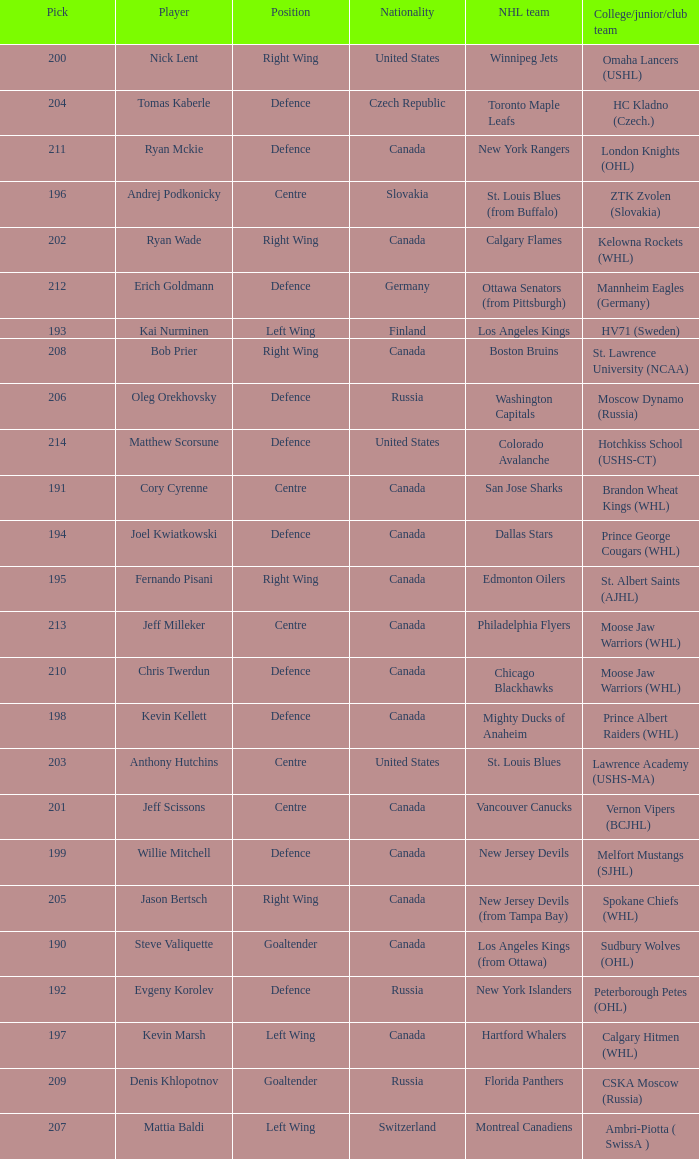Name the number of nationalities for ryan mckie 1.0. 